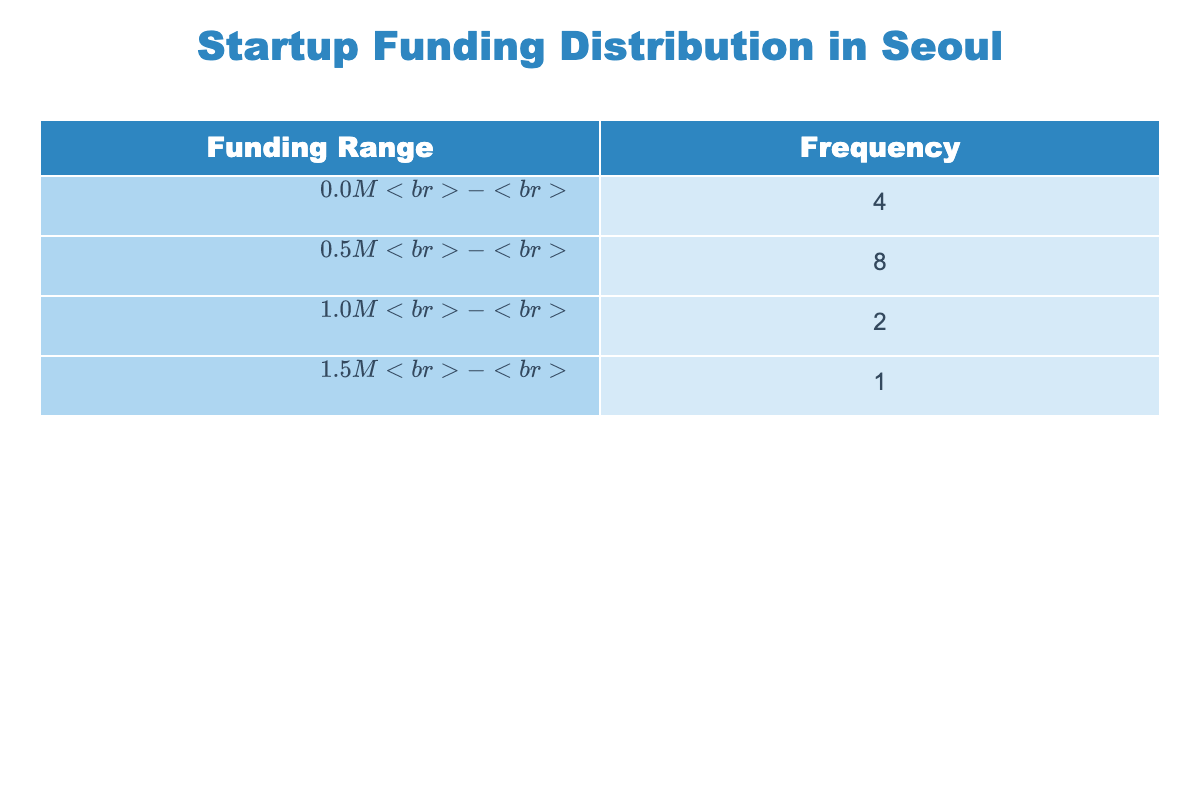What is the funding range with the highest frequency? The table shows that the frequency of various funding ranges is listed. The range that appears most frequently needs to be identified. By reviewing the frequencies, we find that the range with the highest count is the one with the most companies associated with it.
Answer: $500.0M - $1.0M How many companies received funding in the range of $1.0M to $1.5M? This question requires counting the number of companies that fall into the specified funding range in the table. By examining the entries, only one company, EduSmart Technologies, is identified within this range.
Answer: 1 What is the total number of startups listed in the table? To find the total number of startups, we must count each unique entry of companies in the table. After counting, we see there are 15 distinct companies listed.
Answer: 15 Is there a company that received funding above $1.5M? We need to check the funding amounts for each company and determine if any amount exceeds $1.5M. From the data, BioMed Korea is the only company reported to have received funding exceeding this amount.
Answer: Yes What is the average funding amount for companies that received less than $1.0M? We will gather all funding amounts less than $1.0M, list them as (500000, 300000, 750000, 850000, 600000, 400000, 550000, 900000), then sum these values: 500000 + 300000 + 750000 + 850000 + 600000 + 400000 + 550000 + 900000 = 4050000. Dividing by the 8 companies gives the average: 4050000/8 = 506250.
Answer: 506250 How many funding ranges include at least three companies? This requires an examination of each funding range's frequency. We look for ranges that have a frequency count of three or more. By inspecting the frequencies, we find that only the range of $500.0M - $1.0M meets this criterion with four companies.
Answer: 1 